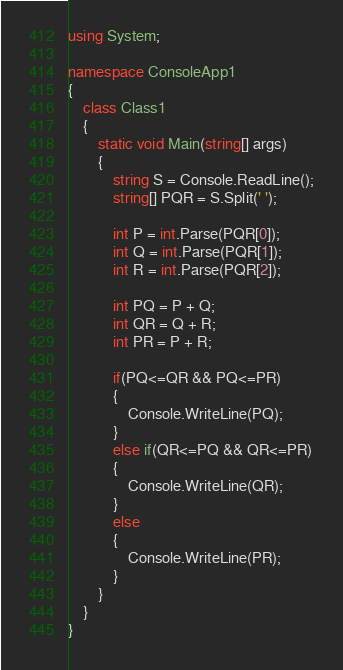Convert code to text. <code><loc_0><loc_0><loc_500><loc_500><_C#_>using System;

namespace ConsoleApp1
{
    class Class1
    {
        static void Main(string[] args)
        {
            string S = Console.ReadLine();
            string[] PQR = S.Split(' ');

            int P = int.Parse(PQR[0]);
            int Q = int.Parse(PQR[1]);
            int R = int.Parse(PQR[2]);

            int PQ = P + Q;
            int QR = Q + R;
            int PR = P + R;

            if(PQ<=QR && PQ<=PR)
            {
                Console.WriteLine(PQ);
            }
            else if(QR<=PQ && QR<=PR)
            {
                Console.WriteLine(QR);
            }
            else
            {
                Console.WriteLine(PR);
            }
        }
    }
}
</code> 